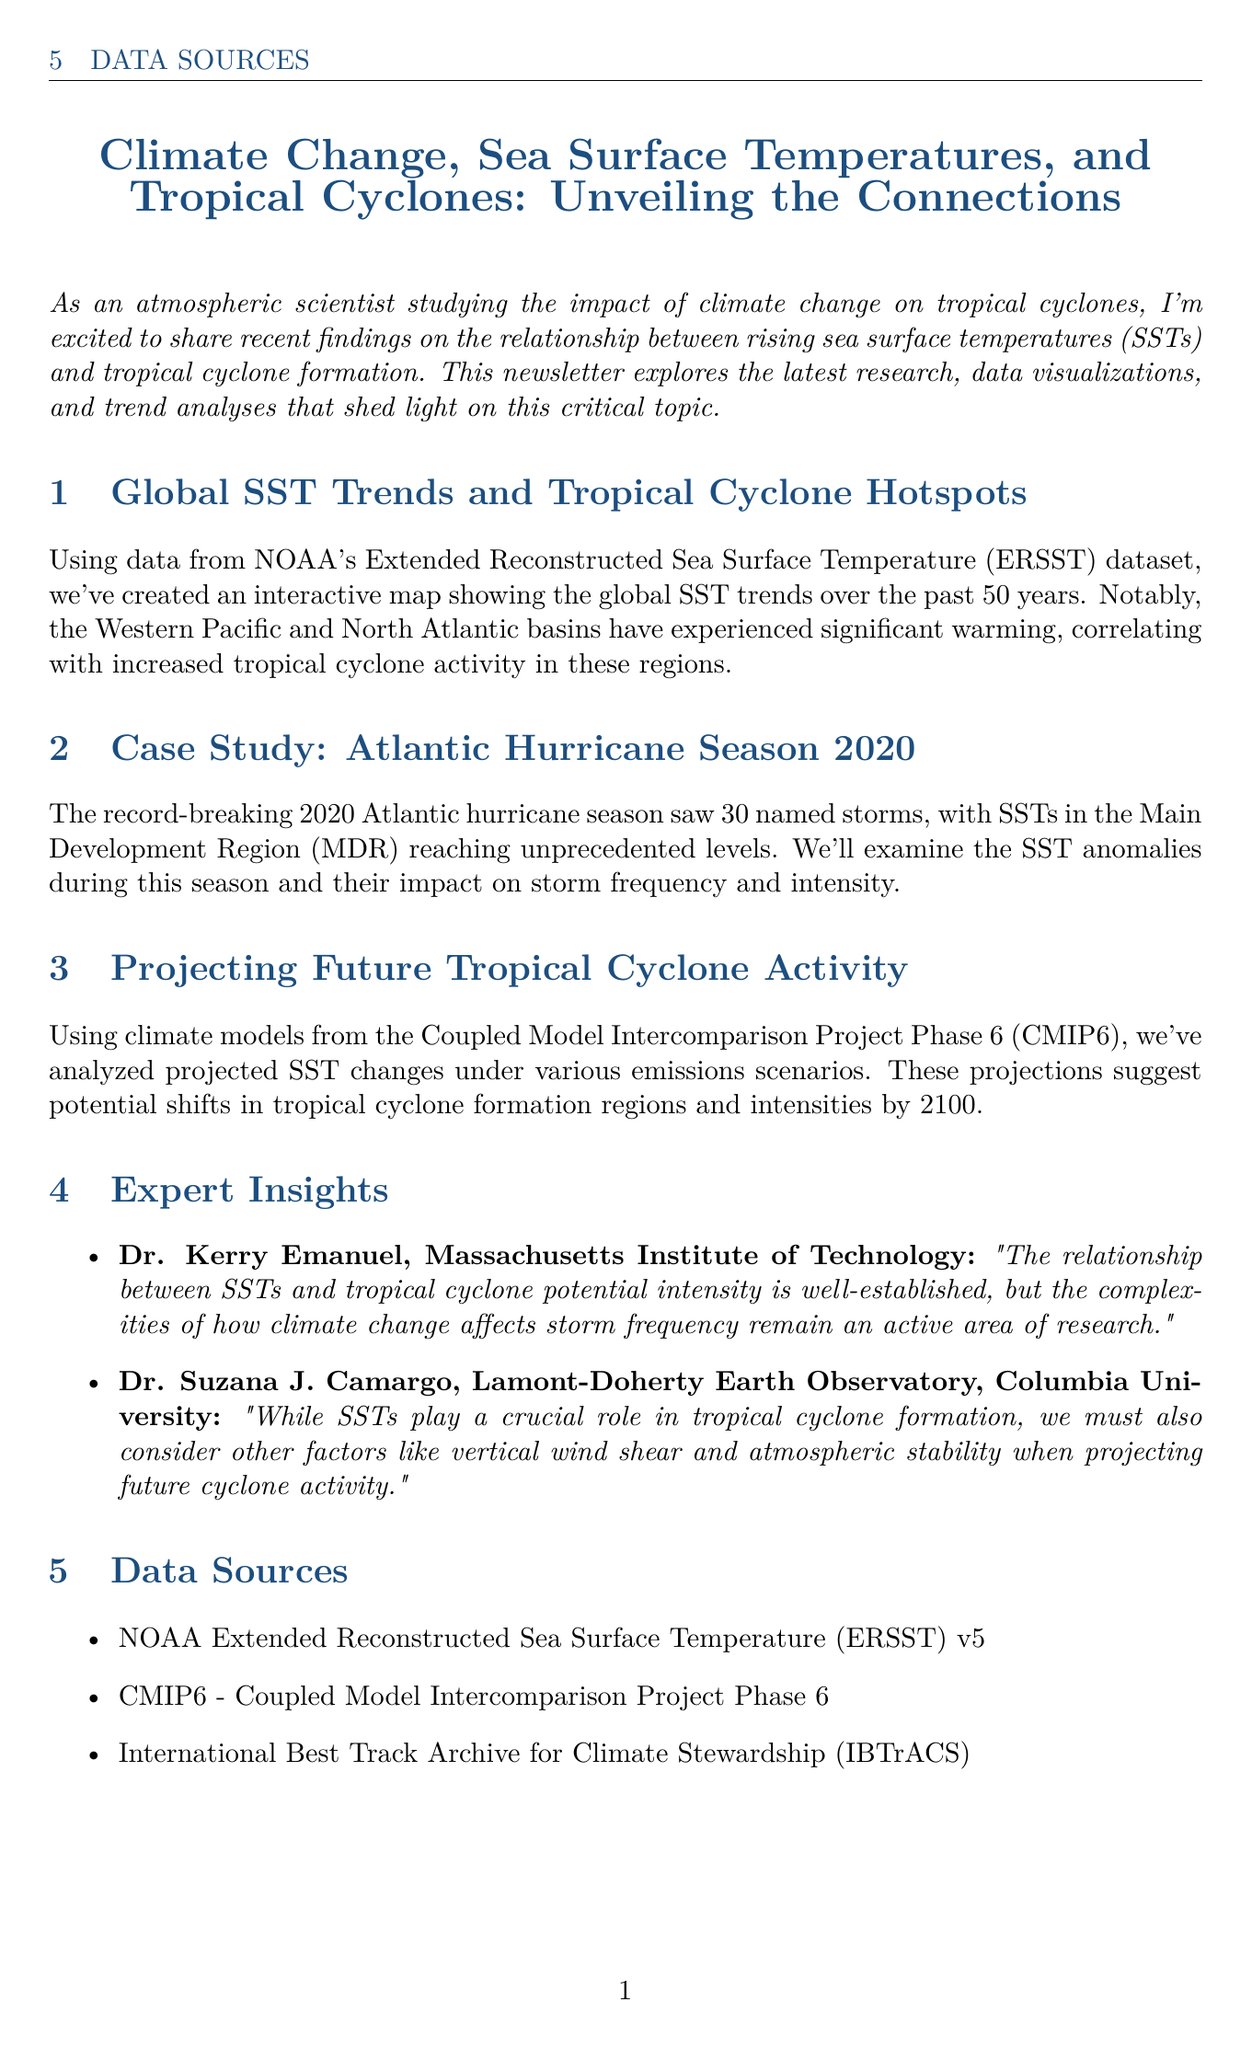What is the title of the newsletter? The title of the newsletter is stated at the beginning of the document.
Answer: Climate Change, Sea Surface Temperatures, and Tropical Cyclones: Unveiling the Connections Which ocean basins showed significant warming? The document specifies that the Western Pacific and North Atlantic basins have experienced significant warming.
Answer: Western Pacific and North Atlantic How many named storms were in the 2020 Atlantic hurricane season? The document provides specific information about the number of named storms during the record-breaking hurricane season.
Answer: 30 What is the designation of the climate models used for future projections? The document mentions the specific project associated with the climate models used in the analysis.
Answer: CMIP6 Who is Dr. Kerry Emanuel affiliated with? The document lists the affiliations of the experts quoted, including Dr. Kerry Emanuel.
Answer: Massachusetts Institute of Technology What year do the SST projections extend to? The projections for SST changes under various emissions scenarios are mentioned within a specific timeframe in the document.
Answer: 2100 What do the SST anomalies in the Main Development Region impact? The document indicates the effects of SST anomalies during a specific hurricane season.
Answer: Storm frequency and intensity What type of data visualization accompanies the case study section? The document describes the type of graphic used in the case study that highlights SST anomalies.
Answer: Time series graph 